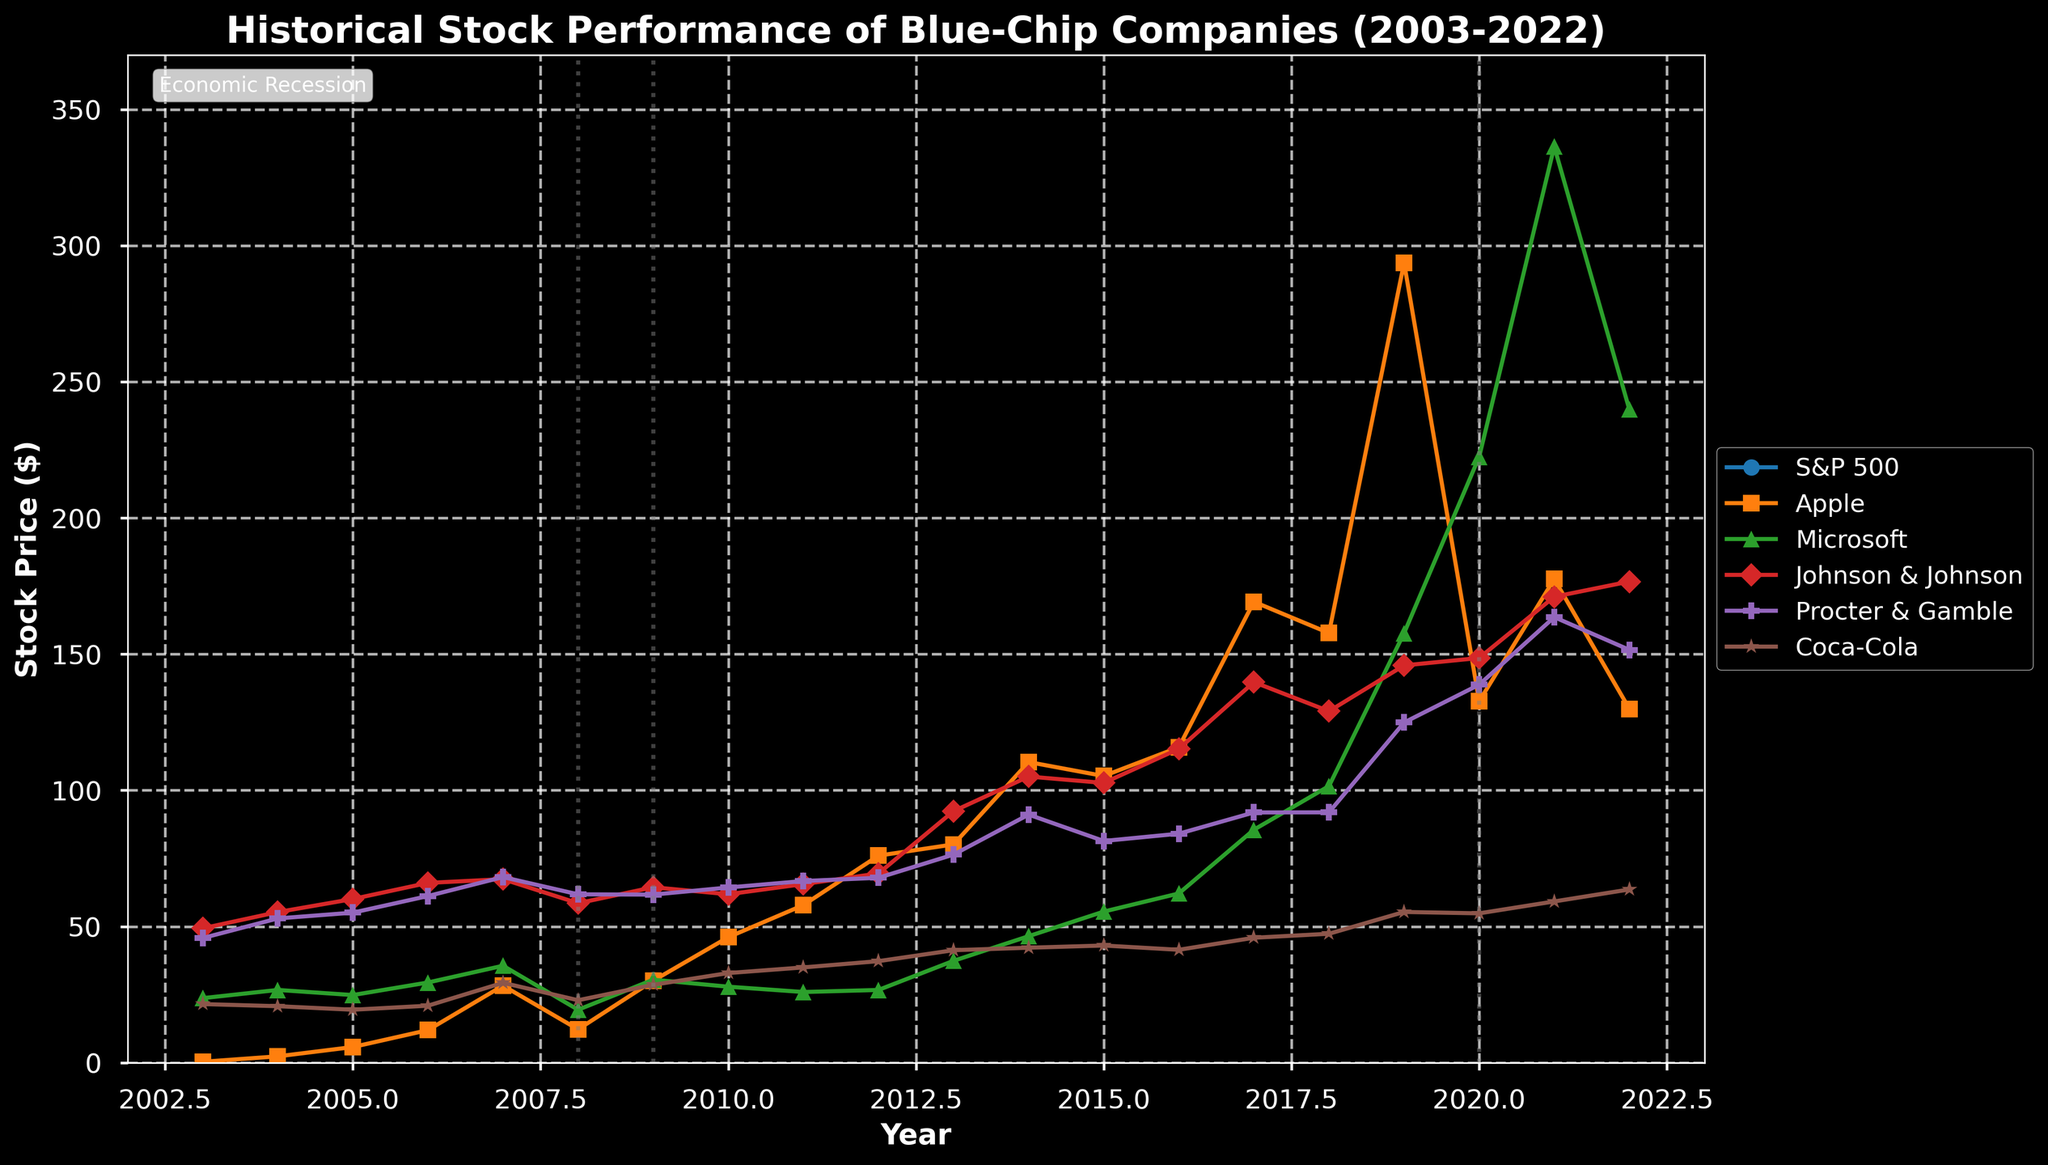Which company had the highest stock price in 2019? To find the highest stock price in 2019, look for the highest point on the plot for that year. The peak in 2019 is Apple at around $293.65.
Answer: Apple How did the stock price of Microsoft change from 2013 to 2021? Identify Microsoft’s stock prices in 2013 and 2021. In 2013, Microsoft’s price was around $37.41, and in 2021, it was about $336.32. Subtract the 2013 price from the 2021 price to find the change: $336.32 - $37.41 = $298.91.
Answer: Increased by $298.91 Which years experienced an economic recession according to the chart? Economic recession years are marked by vertical dotted lines. The years with such lines are 2008, 2009, and 2020.
Answer: 2008, 2009, 2020 Compare the average stock price of Coca-Cola during recession years to non-recession years. Find the stock prices of Coca-Cola during recession years (2008, 2009, 2020) and non-recession years (all other years). Recession years: $22.94, $28.60, $54.84. Average = (22.94 + 28.60 + 54.84) / 3 = 35.46. Non-recession years: (sum of all other years' prices) / 17. Average for recession years is 35.46, which is visibly lower compared to non-recession years.
Answer: Lower during recession years Which years did Apple outperform the S&P 500 in stock price? Compare Apple’s stock price to the S&P 500 each year by observing the two lines. Apple outperformed the S&P 500 visibly in 2019 and 2020, where its price is higher than the S&P 500 index.
Answer: 2019, 2020 What is the trend in Johnson & Johnson’s stock price over the 20 years? Examine the trend line of Johnson & Johnson over 20 years; it starts lower in 2003, has overall increased steadily with minor fluctuations, reaching higher in 2022.
Answer: Upward trend Which two companies had the biggest drop in stock prices during the 2008 recession? Identify stock prices for all companies in 2007 and 2008. Calculate the drop for each: S&P 500: 1468.36 to 903.25; Apple: 28.30 to 12.24, etc. The two largest drops are for S&P 500 and Apple.
Answer: S&P 500 and Apple What is the total increase in stock price for Procter & Gamble from 2003 to 2022? Find Procter & Gamble’s stock price in 2003 and 2022. For 2003 it is $45.76 and for 2022 it is $151.58. Calculate the total increase: $151.58 - $45.76 = $105.82.
Answer: $105.82 How did Johnson & Johnson’s stock respond to the 2008 recession compared to Microsoft? Compare both companies' stock prices in 2007 and 2008: Johnson & Johnson went from $67.38 to $58.56, a drop of $8.82. Microsoft dropped from $35.60 to $19.44, a difference of $16.16. Microsoft had a larger drop than Johnson & Johnson.
Answer: Johnson & Johnson had a smaller drop Between Apple and Coca-Cola, which company's stock showed more volatility in the given period? Compare the variation in stock prices of both companies visually. Apple shows steeper and more frequent changes in prices compared to Coca-Cola.
Answer: Apple 